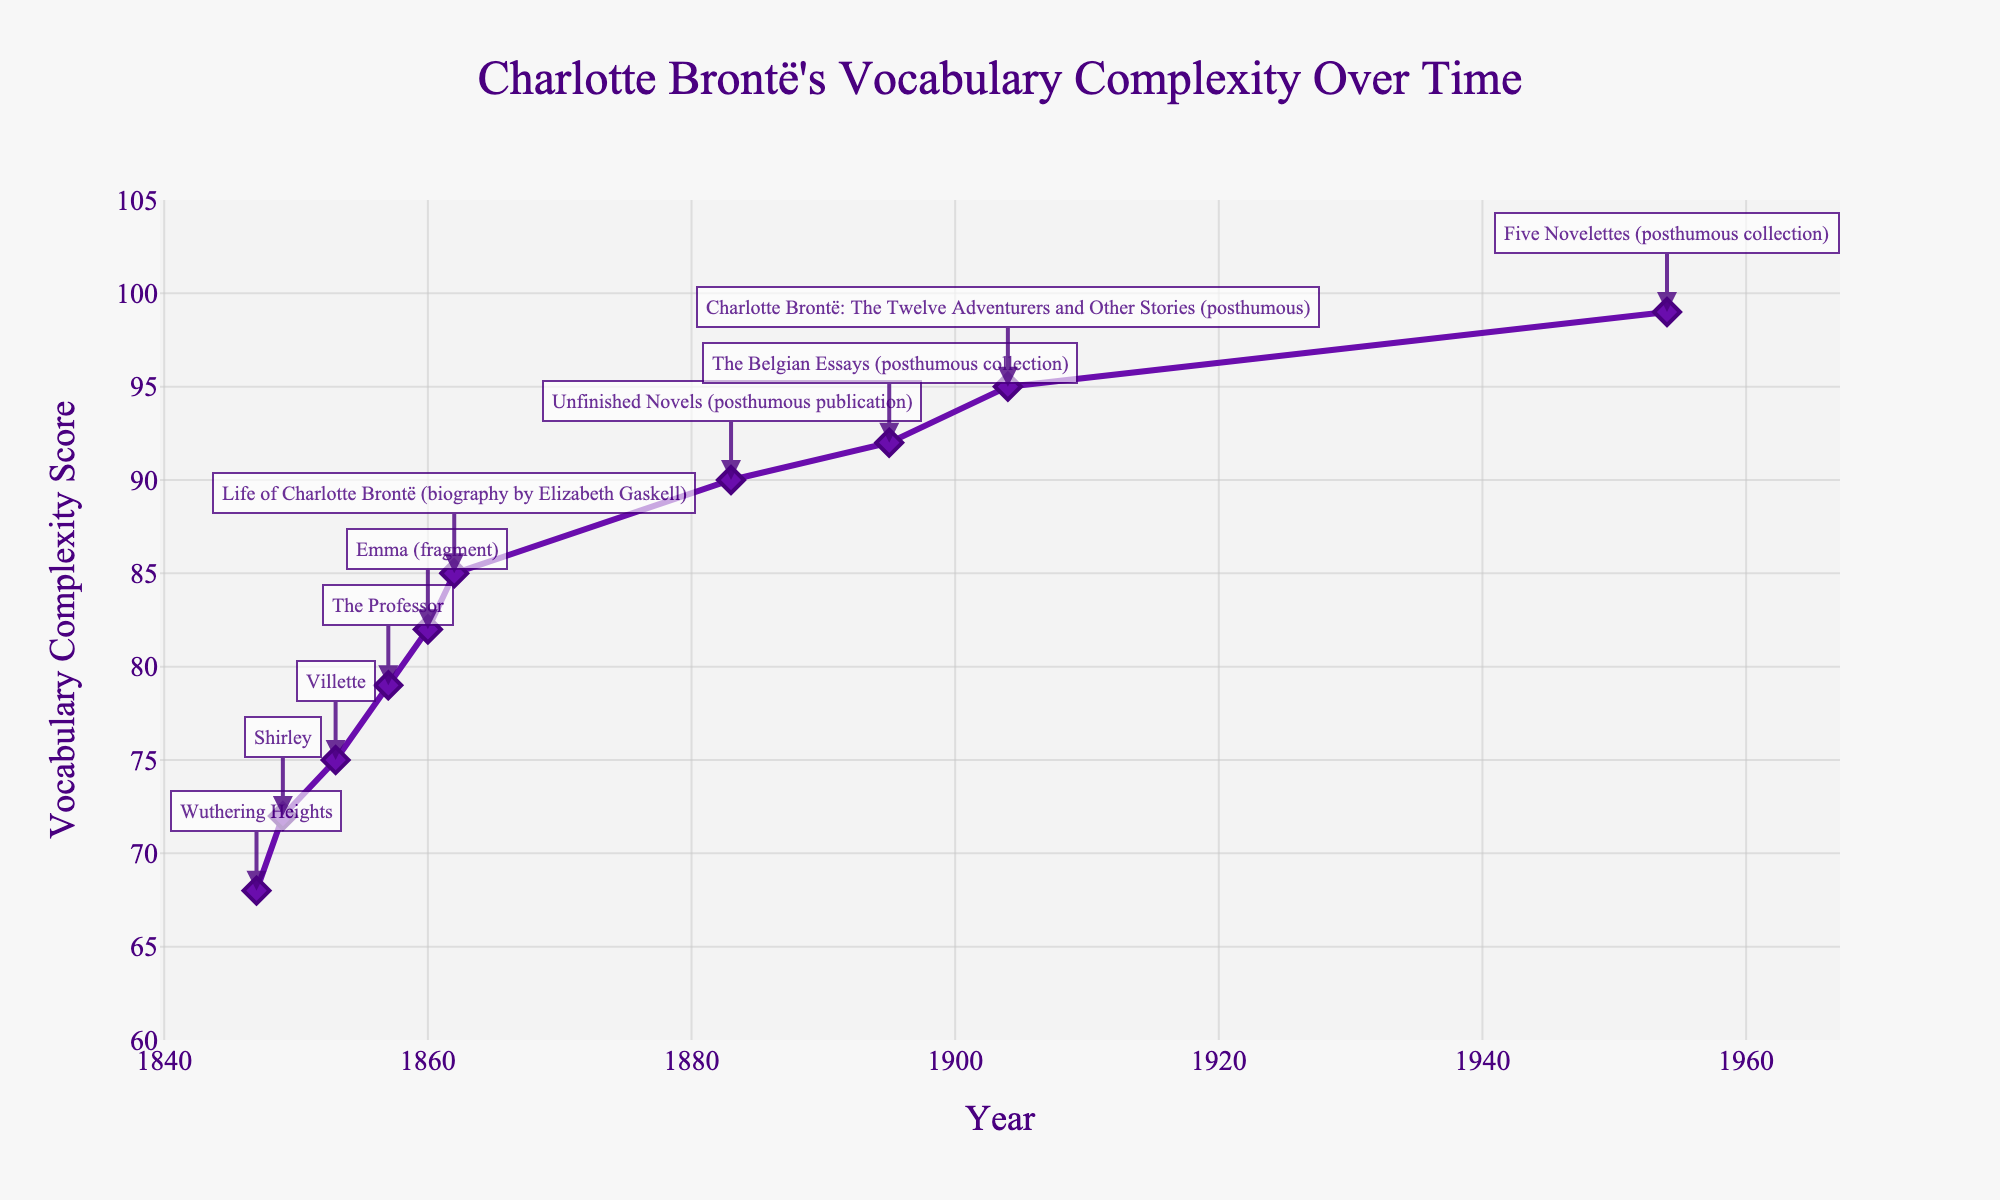How does the vocabulary complexity score change from "Wuthering Heights" (1847) to "Shirley" (1849)? To find the change, subtract the vocabulary complexity score of "Wuthering Heights" (1847) from that of "Shirley" (1849). The scores are 68 and 72 respectively, so 72 - 68 = 4.
Answer: 4 Which notable work is associated with a vocabulary complexity score of 85? Look at the figure, identify the data point with a score of 85, and refer to its annotation. The notable work for 85 is "Life of Charlotte Brontë (biography by Elizabeth Gaskell)" in 1862.
Answer: "Life of Charlotte Brontë (biography by Elizabeth Gaskell)" What is the trend in vocabulary complexity scores from 1847 to 1904 as shown in the figure? Examine the progression of data points from 1847 (68) to 1904 (95). The scores generally increase over time, indicating a trend of increasing vocabulary complexity.
Answer: Increasing Considering the full range of years in the plot, which year has the highest vocabulary complexity score? Look for the data point with the highest value on the y-axis. The year with a score of 99 is 1954.
Answer: 1954 Compare the vocabulary complexity scores between "Villette" (1853) and "The Professor" (1857). Which one is higher, and by how much? Identify the scores for "Villette" (75) and "The Professor" (79). Subtract the lesser from the greater: 79 - 75 = 4. "The Professor" is higher by 4 points.
Answer: "The Professor" is higher by 4 points What is the average vocabulary complexity score for the works published before 1860? The scores before 1860 are [(68, 72, 75, 79)]. Calculate the average: (68 + 72 + 75 + 79) / 4 = 73.5.
Answer: 73.5 What is the overall increase in vocabulary complexity from "Shirley" (1849) to "Emma (fragment)" (1860)? Subtract the score of "Shirley" (72) from "Emma (fragment)" (82): 82 - 72 = 10.
Answer: 10 Which notable works were published posthumously and what are their respective vocabulary complexity scores? Look for works published after the author's death and list their scores. These works include: 
"Unfinished Novels" (90), 
"The Belgian Essays" (92), 
"Charlotte Brontë: The Twelve Adventurers and Other Stories" (95), 
"Five Novelettes" (99).
Answer: Unfinished Novels (90), The Belgian Essays (92), Charlotte Brontë: The Twelve Adventurers and Other Stories (95), Five Novelettes (99) What is the difference in the vocabulary complexity scores between the first work ("Wuthering Heights" - 1847) and the last work ("Five Novelettes" - 1954)? Subtract the score of the first work from the last work: 99 - 68 = 31.
Answer: 31 